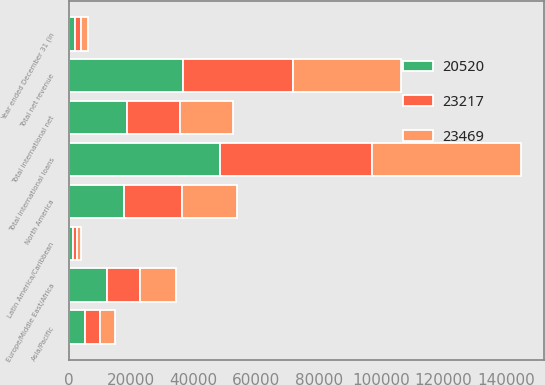<chart> <loc_0><loc_0><loc_500><loc_500><stacked_bar_chart><ecel><fcel>Year ended December 31 (in<fcel>Europe/Middle East/Africa<fcel>Asia/Pacific<fcel>Latin America/Caribbean<fcel>Total international net<fcel>North America<fcel>Total net revenue<fcel>Total international loans<nl><fcel>20520<fcel>2018<fcel>12102<fcel>5219<fcel>1394<fcel>18715<fcel>17733<fcel>36448<fcel>48362<nl><fcel>23469<fcel>2017<fcel>11328<fcel>4525<fcel>1125<fcel>16978<fcel>17679<fcel>34657<fcel>47725<nl><fcel>23217<fcel>2016<fcel>10786<fcel>4915<fcel>1225<fcel>16926<fcel>18414<fcel>35340<fcel>48811<nl></chart> 